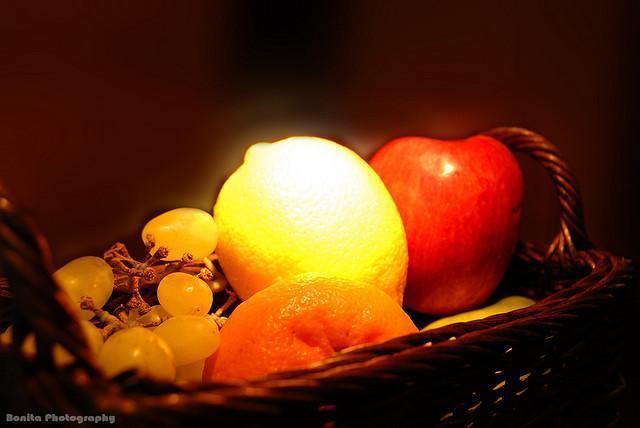How many types of fruit are there in the image?
Give a very brief answer. 4. How many types of fruit are in the image?
Give a very brief answer. 4. How many apples are there?
Give a very brief answer. 1. 